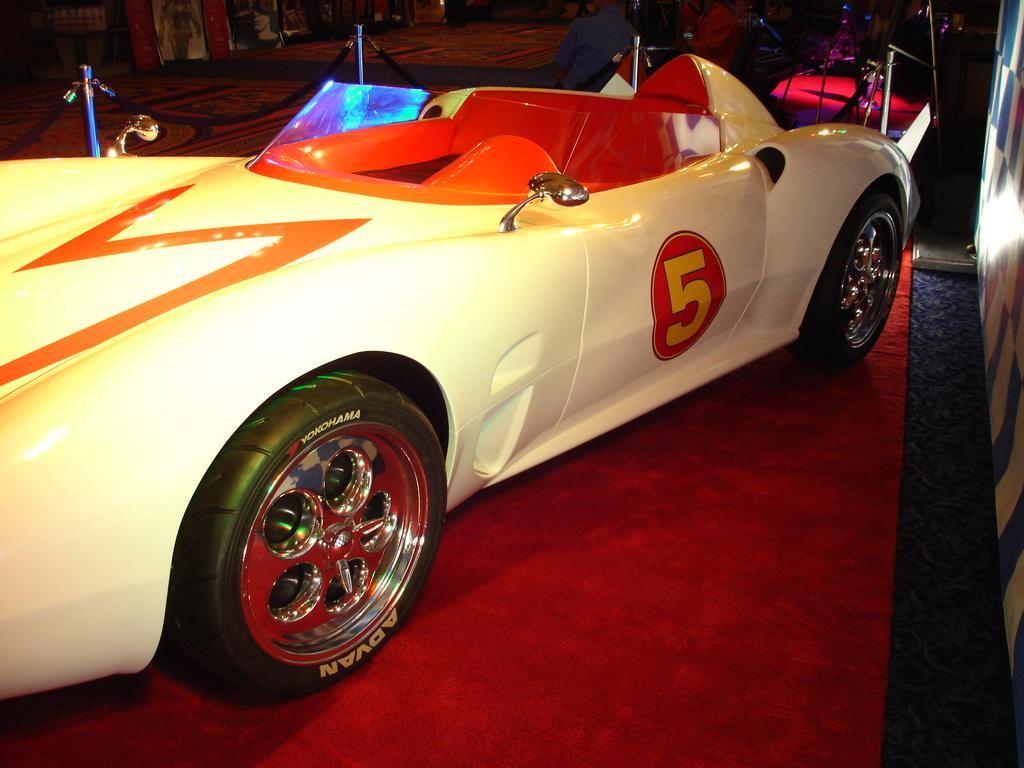Please provide a concise description of this image. In this image, we can see a car parked on the red carpet. On the right side of the image, we can see white and blue color board. At the top of the image, we can see pole barriers, people, banner stands and some objects. 